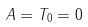Convert formula to latex. <formula><loc_0><loc_0><loc_500><loc_500>A = T _ { 0 } = 0</formula> 